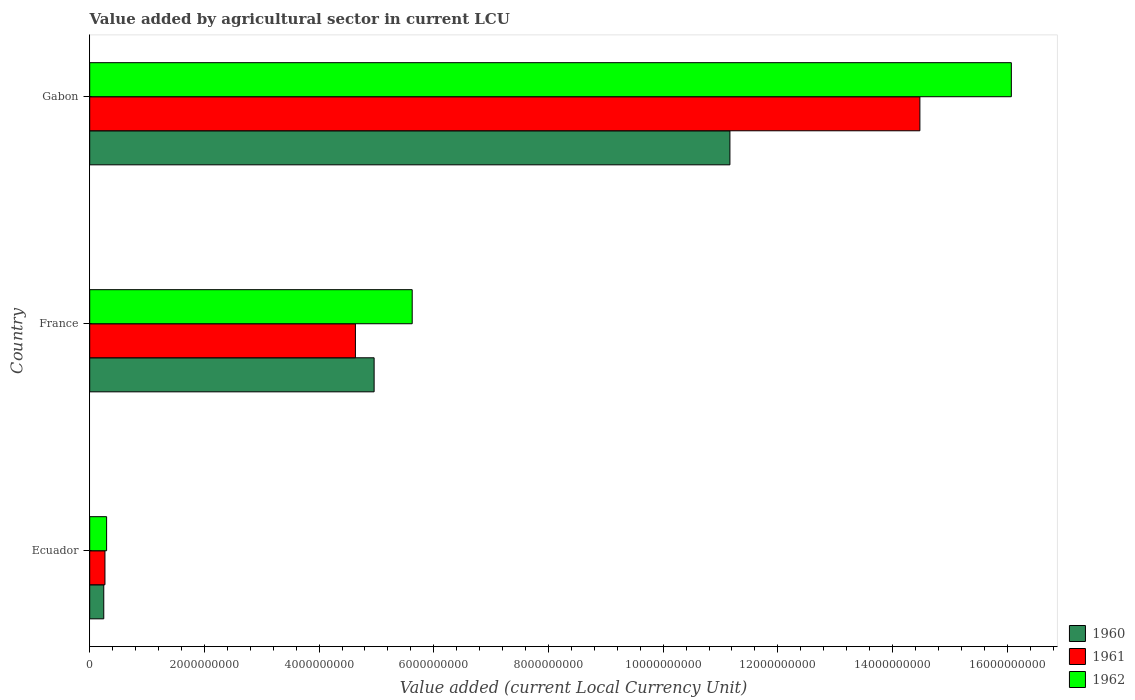How many different coloured bars are there?
Your response must be concise. 3. How many bars are there on the 3rd tick from the bottom?
Your response must be concise. 3. What is the label of the 1st group of bars from the top?
Ensure brevity in your answer.  Gabon. What is the value added by agricultural sector in 1962 in France?
Offer a very short reply. 5.62e+09. Across all countries, what is the maximum value added by agricultural sector in 1961?
Offer a terse response. 1.45e+1. Across all countries, what is the minimum value added by agricultural sector in 1962?
Provide a succinct answer. 2.95e+08. In which country was the value added by agricultural sector in 1961 maximum?
Offer a terse response. Gabon. In which country was the value added by agricultural sector in 1960 minimum?
Offer a very short reply. Ecuador. What is the total value added by agricultural sector in 1961 in the graph?
Make the answer very short. 1.94e+1. What is the difference between the value added by agricultural sector in 1961 in Ecuador and that in France?
Provide a succinct answer. -4.37e+09. What is the difference between the value added by agricultural sector in 1962 in France and the value added by agricultural sector in 1961 in Ecuador?
Your response must be concise. 5.36e+09. What is the average value added by agricultural sector in 1960 per country?
Make the answer very short. 5.46e+09. What is the difference between the value added by agricultural sector in 1962 and value added by agricultural sector in 1961 in Ecuador?
Offer a very short reply. 2.89e+07. What is the ratio of the value added by agricultural sector in 1960 in France to that in Gabon?
Offer a very short reply. 0.44. What is the difference between the highest and the second highest value added by agricultural sector in 1961?
Keep it short and to the point. 9.84e+09. What is the difference between the highest and the lowest value added by agricultural sector in 1960?
Provide a short and direct response. 1.09e+1. In how many countries, is the value added by agricultural sector in 1962 greater than the average value added by agricultural sector in 1962 taken over all countries?
Keep it short and to the point. 1. Is it the case that in every country, the sum of the value added by agricultural sector in 1960 and value added by agricultural sector in 1961 is greater than the value added by agricultural sector in 1962?
Provide a short and direct response. Yes. Are all the bars in the graph horizontal?
Offer a terse response. Yes. Are the values on the major ticks of X-axis written in scientific E-notation?
Keep it short and to the point. No. Does the graph contain any zero values?
Your response must be concise. No. What is the title of the graph?
Make the answer very short. Value added by agricultural sector in current LCU. Does "2005" appear as one of the legend labels in the graph?
Provide a short and direct response. No. What is the label or title of the X-axis?
Offer a very short reply. Value added (current Local Currency Unit). What is the Value added (current Local Currency Unit) of 1960 in Ecuador?
Give a very brief answer. 2.45e+08. What is the Value added (current Local Currency Unit) of 1961 in Ecuador?
Offer a terse response. 2.66e+08. What is the Value added (current Local Currency Unit) in 1962 in Ecuador?
Ensure brevity in your answer.  2.95e+08. What is the Value added (current Local Currency Unit) in 1960 in France?
Offer a terse response. 4.96e+09. What is the Value added (current Local Currency Unit) in 1961 in France?
Provide a short and direct response. 4.63e+09. What is the Value added (current Local Currency Unit) of 1962 in France?
Your response must be concise. 5.62e+09. What is the Value added (current Local Currency Unit) in 1960 in Gabon?
Give a very brief answer. 1.12e+1. What is the Value added (current Local Currency Unit) of 1961 in Gabon?
Your answer should be very brief. 1.45e+1. What is the Value added (current Local Currency Unit) in 1962 in Gabon?
Your answer should be compact. 1.61e+1. Across all countries, what is the maximum Value added (current Local Currency Unit) in 1960?
Provide a short and direct response. 1.12e+1. Across all countries, what is the maximum Value added (current Local Currency Unit) of 1961?
Provide a short and direct response. 1.45e+1. Across all countries, what is the maximum Value added (current Local Currency Unit) in 1962?
Keep it short and to the point. 1.61e+1. Across all countries, what is the minimum Value added (current Local Currency Unit) of 1960?
Your answer should be compact. 2.45e+08. Across all countries, what is the minimum Value added (current Local Currency Unit) in 1961?
Provide a succinct answer. 2.66e+08. Across all countries, what is the minimum Value added (current Local Currency Unit) in 1962?
Your response must be concise. 2.95e+08. What is the total Value added (current Local Currency Unit) in 1960 in the graph?
Your answer should be very brief. 1.64e+1. What is the total Value added (current Local Currency Unit) in 1961 in the graph?
Make the answer very short. 1.94e+1. What is the total Value added (current Local Currency Unit) of 1962 in the graph?
Provide a short and direct response. 2.20e+1. What is the difference between the Value added (current Local Currency Unit) of 1960 in Ecuador and that in France?
Make the answer very short. -4.71e+09. What is the difference between the Value added (current Local Currency Unit) of 1961 in Ecuador and that in France?
Ensure brevity in your answer.  -4.37e+09. What is the difference between the Value added (current Local Currency Unit) in 1962 in Ecuador and that in France?
Offer a very short reply. -5.33e+09. What is the difference between the Value added (current Local Currency Unit) of 1960 in Ecuador and that in Gabon?
Ensure brevity in your answer.  -1.09e+1. What is the difference between the Value added (current Local Currency Unit) of 1961 in Ecuador and that in Gabon?
Offer a terse response. -1.42e+1. What is the difference between the Value added (current Local Currency Unit) in 1962 in Ecuador and that in Gabon?
Offer a terse response. -1.58e+1. What is the difference between the Value added (current Local Currency Unit) of 1960 in France and that in Gabon?
Make the answer very short. -6.20e+09. What is the difference between the Value added (current Local Currency Unit) in 1961 in France and that in Gabon?
Offer a terse response. -9.84e+09. What is the difference between the Value added (current Local Currency Unit) of 1962 in France and that in Gabon?
Offer a terse response. -1.04e+1. What is the difference between the Value added (current Local Currency Unit) in 1960 in Ecuador and the Value added (current Local Currency Unit) in 1961 in France?
Provide a succinct answer. -4.39e+09. What is the difference between the Value added (current Local Currency Unit) of 1960 in Ecuador and the Value added (current Local Currency Unit) of 1962 in France?
Provide a short and direct response. -5.38e+09. What is the difference between the Value added (current Local Currency Unit) of 1961 in Ecuador and the Value added (current Local Currency Unit) of 1962 in France?
Offer a terse response. -5.36e+09. What is the difference between the Value added (current Local Currency Unit) of 1960 in Ecuador and the Value added (current Local Currency Unit) of 1961 in Gabon?
Offer a very short reply. -1.42e+1. What is the difference between the Value added (current Local Currency Unit) of 1960 in Ecuador and the Value added (current Local Currency Unit) of 1962 in Gabon?
Make the answer very short. -1.58e+1. What is the difference between the Value added (current Local Currency Unit) in 1961 in Ecuador and the Value added (current Local Currency Unit) in 1962 in Gabon?
Make the answer very short. -1.58e+1. What is the difference between the Value added (current Local Currency Unit) in 1960 in France and the Value added (current Local Currency Unit) in 1961 in Gabon?
Your answer should be compact. -9.52e+09. What is the difference between the Value added (current Local Currency Unit) in 1960 in France and the Value added (current Local Currency Unit) in 1962 in Gabon?
Provide a short and direct response. -1.11e+1. What is the difference between the Value added (current Local Currency Unit) of 1961 in France and the Value added (current Local Currency Unit) of 1962 in Gabon?
Provide a short and direct response. -1.14e+1. What is the average Value added (current Local Currency Unit) in 1960 per country?
Your answer should be compact. 5.46e+09. What is the average Value added (current Local Currency Unit) of 1961 per country?
Provide a short and direct response. 6.46e+09. What is the average Value added (current Local Currency Unit) in 1962 per country?
Ensure brevity in your answer.  7.33e+09. What is the difference between the Value added (current Local Currency Unit) in 1960 and Value added (current Local Currency Unit) in 1961 in Ecuador?
Offer a very short reply. -2.09e+07. What is the difference between the Value added (current Local Currency Unit) of 1960 and Value added (current Local Currency Unit) of 1962 in Ecuador?
Your answer should be compact. -4.98e+07. What is the difference between the Value added (current Local Currency Unit) of 1961 and Value added (current Local Currency Unit) of 1962 in Ecuador?
Make the answer very short. -2.89e+07. What is the difference between the Value added (current Local Currency Unit) of 1960 and Value added (current Local Currency Unit) of 1961 in France?
Keep it short and to the point. 3.26e+08. What is the difference between the Value added (current Local Currency Unit) in 1960 and Value added (current Local Currency Unit) in 1962 in France?
Provide a succinct answer. -6.64e+08. What is the difference between the Value added (current Local Currency Unit) in 1961 and Value added (current Local Currency Unit) in 1962 in France?
Your response must be concise. -9.90e+08. What is the difference between the Value added (current Local Currency Unit) in 1960 and Value added (current Local Currency Unit) in 1961 in Gabon?
Offer a very short reply. -3.31e+09. What is the difference between the Value added (current Local Currency Unit) in 1960 and Value added (current Local Currency Unit) in 1962 in Gabon?
Offer a terse response. -4.91e+09. What is the difference between the Value added (current Local Currency Unit) of 1961 and Value added (current Local Currency Unit) of 1962 in Gabon?
Offer a very short reply. -1.59e+09. What is the ratio of the Value added (current Local Currency Unit) in 1960 in Ecuador to that in France?
Offer a terse response. 0.05. What is the ratio of the Value added (current Local Currency Unit) in 1961 in Ecuador to that in France?
Provide a succinct answer. 0.06. What is the ratio of the Value added (current Local Currency Unit) in 1962 in Ecuador to that in France?
Your answer should be compact. 0.05. What is the ratio of the Value added (current Local Currency Unit) of 1960 in Ecuador to that in Gabon?
Offer a terse response. 0.02. What is the ratio of the Value added (current Local Currency Unit) in 1961 in Ecuador to that in Gabon?
Provide a succinct answer. 0.02. What is the ratio of the Value added (current Local Currency Unit) in 1962 in Ecuador to that in Gabon?
Give a very brief answer. 0.02. What is the ratio of the Value added (current Local Currency Unit) in 1960 in France to that in Gabon?
Ensure brevity in your answer.  0.44. What is the ratio of the Value added (current Local Currency Unit) of 1961 in France to that in Gabon?
Provide a succinct answer. 0.32. What is the ratio of the Value added (current Local Currency Unit) in 1962 in France to that in Gabon?
Offer a very short reply. 0.35. What is the difference between the highest and the second highest Value added (current Local Currency Unit) of 1960?
Provide a short and direct response. 6.20e+09. What is the difference between the highest and the second highest Value added (current Local Currency Unit) of 1961?
Provide a succinct answer. 9.84e+09. What is the difference between the highest and the second highest Value added (current Local Currency Unit) of 1962?
Your response must be concise. 1.04e+1. What is the difference between the highest and the lowest Value added (current Local Currency Unit) of 1960?
Make the answer very short. 1.09e+1. What is the difference between the highest and the lowest Value added (current Local Currency Unit) in 1961?
Ensure brevity in your answer.  1.42e+1. What is the difference between the highest and the lowest Value added (current Local Currency Unit) of 1962?
Make the answer very short. 1.58e+1. 